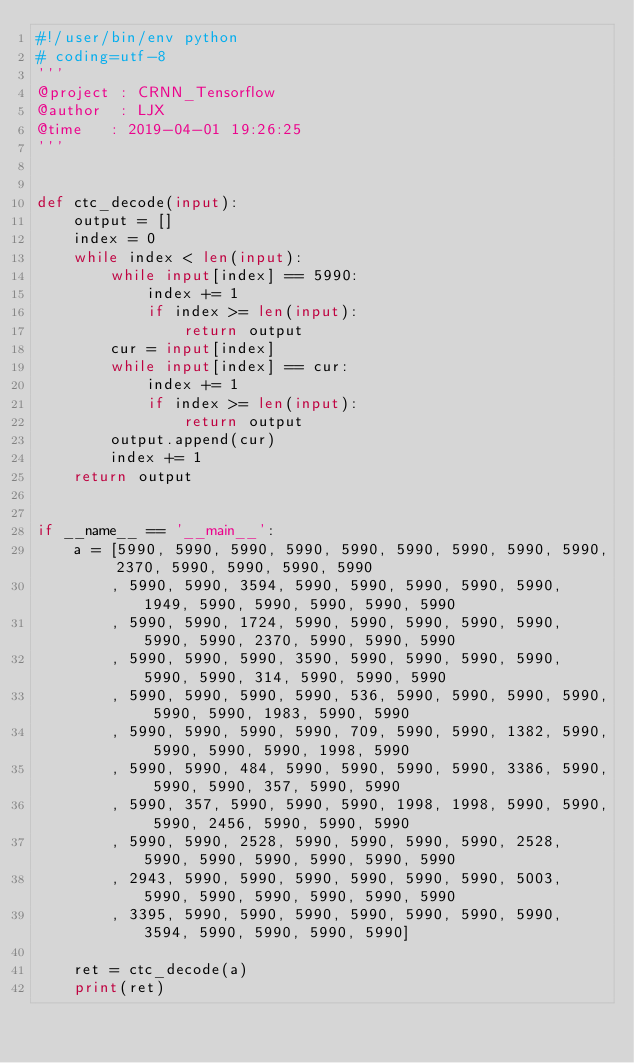<code> <loc_0><loc_0><loc_500><loc_500><_Python_>#!/user/bin/env python
# coding=utf-8
'''
@project : CRNN_Tensorflow
@author  : LJX
@time   : 2019-04-01 19:26:25
'''


def ctc_decode(input):
    output = []
    index = 0
    while index < len(input):
        while input[index] == 5990:
            index += 1
            if index >= len(input):
                return output
        cur = input[index]
        while input[index] == cur:
            index += 1
            if index >= len(input):
                return output
        output.append(cur)
        index += 1
    return output


if __name__ == '__main__':
    a = [5990, 5990, 5990, 5990, 5990, 5990, 5990, 5990, 5990, 2370, 5990, 5990, 5990, 5990
        , 5990, 5990, 3594, 5990, 5990, 5990, 5990, 5990, 1949, 5990, 5990, 5990, 5990, 5990
        , 5990, 5990, 1724, 5990, 5990, 5990, 5990, 5990, 5990, 5990, 2370, 5990, 5990, 5990
        , 5990, 5990, 5990, 3590, 5990, 5990, 5990, 5990, 5990, 5990, 314, 5990, 5990, 5990
        , 5990, 5990, 5990, 5990, 536, 5990, 5990, 5990, 5990, 5990, 5990, 1983, 5990, 5990
        , 5990, 5990, 5990, 5990, 709, 5990, 5990, 1382, 5990, 5990, 5990, 5990, 1998, 5990
        , 5990, 5990, 484, 5990, 5990, 5990, 5990, 3386, 5990, 5990, 5990, 357, 5990, 5990
        , 5990, 357, 5990, 5990, 5990, 1998, 1998, 5990, 5990, 5990, 2456, 5990, 5990, 5990
        , 5990, 5990, 2528, 5990, 5990, 5990, 5990, 2528, 5990, 5990, 5990, 5990, 5990, 5990
        , 2943, 5990, 5990, 5990, 5990, 5990, 5990, 5003, 5990, 5990, 5990, 5990, 5990, 5990
        , 3395, 5990, 5990, 5990, 5990, 5990, 5990, 5990, 3594, 5990, 5990, 5990, 5990]

    ret = ctc_decode(a)
    print(ret)
</code> 